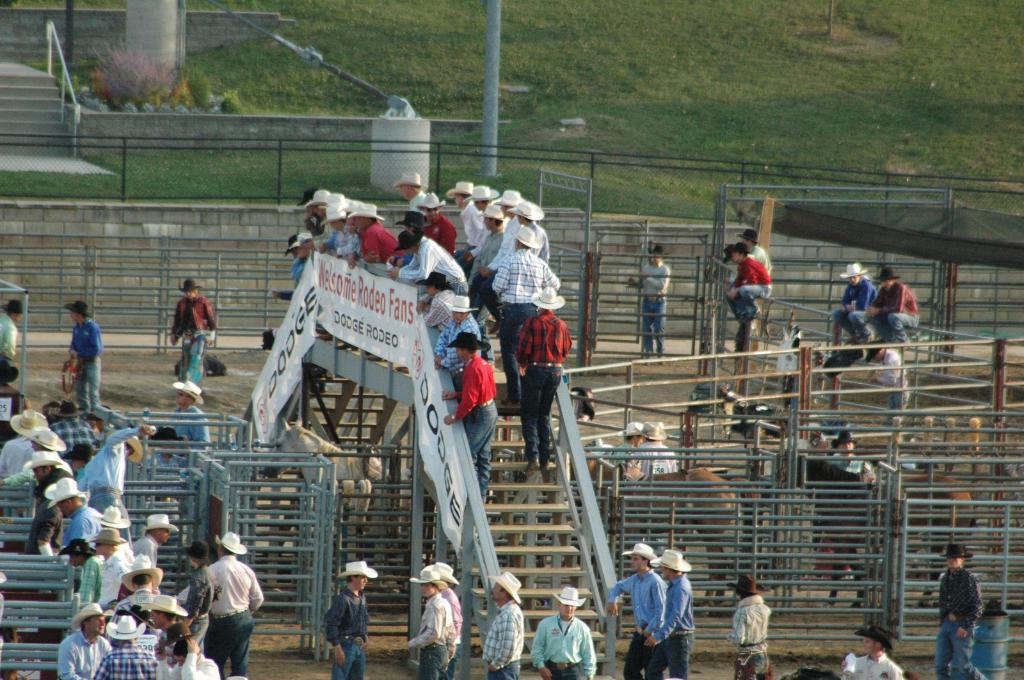In one or two sentences, can you explain what this image depicts? As we can see in the image there are stairs, iron rods, banners, few people here and there, fence and grass. 